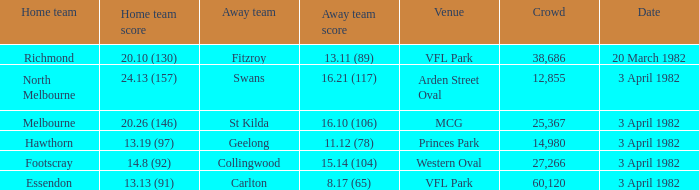What score did the home team of north melbourne get? 24.13 (157). 